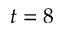<formula> <loc_0><loc_0><loc_500><loc_500>t = 8</formula> 